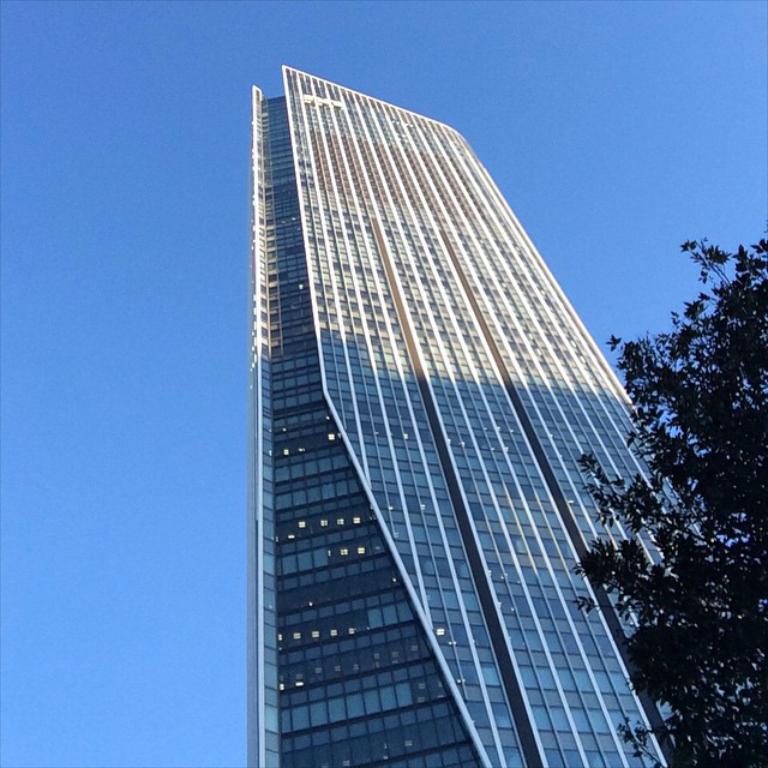Describe this image in one or two sentences. In this image we can see a building and lights in it. We can also see the sky, on the right side there is a tree. 